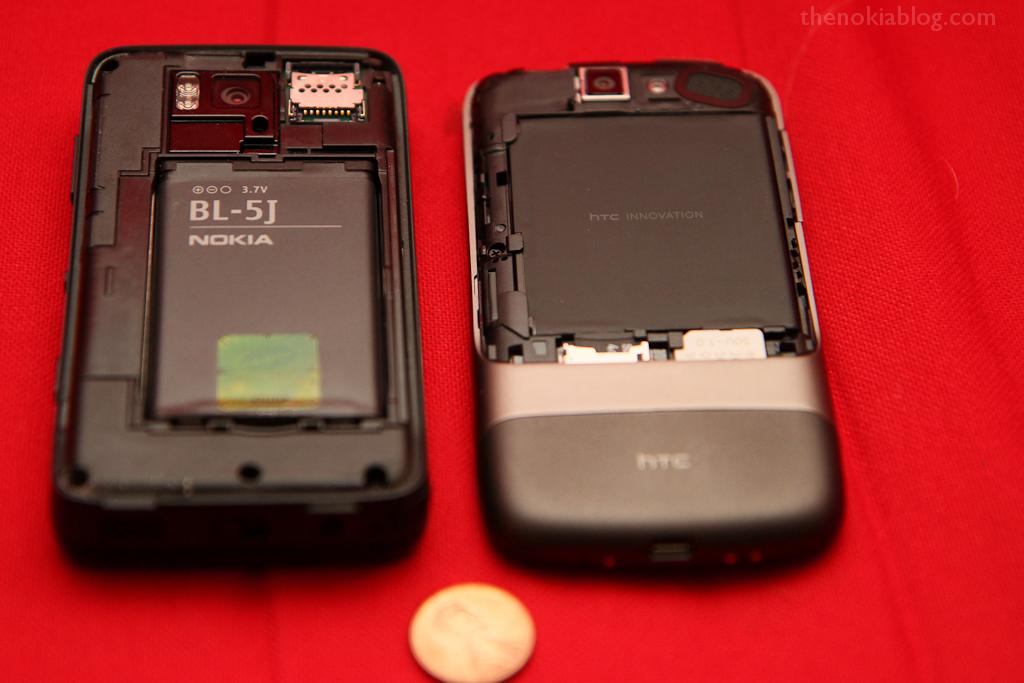What manufacturer makes this phone?
Your answer should be compact. Nokia. 